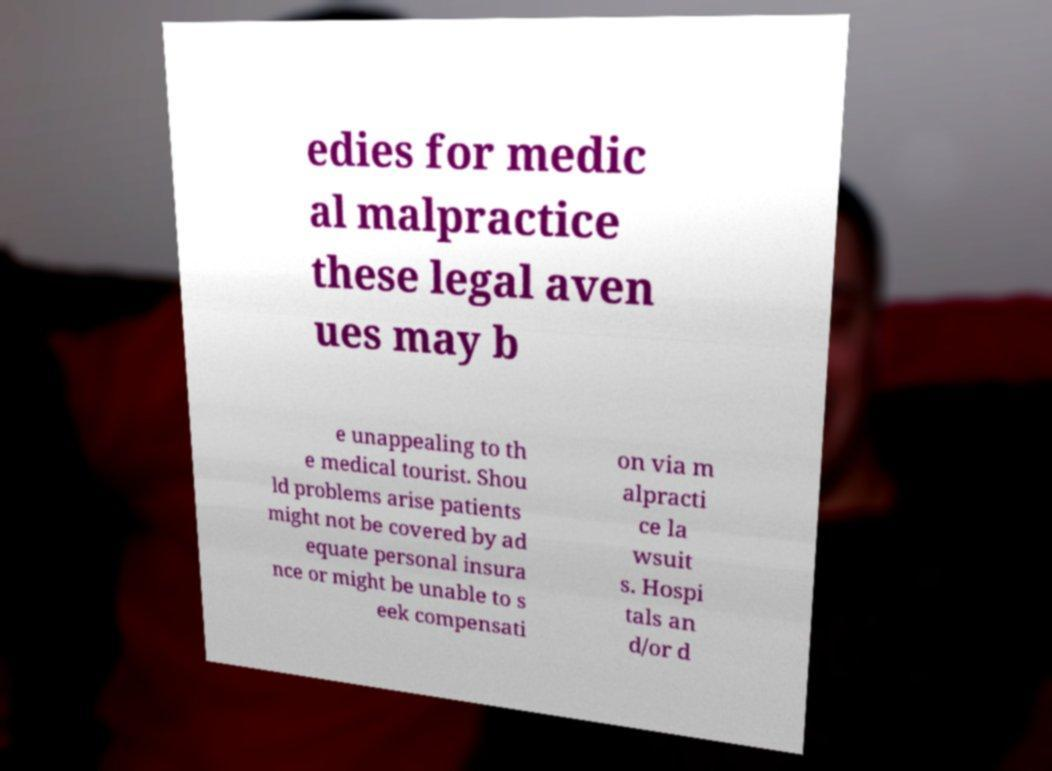Could you assist in decoding the text presented in this image and type it out clearly? edies for medic al malpractice these legal aven ues may b e unappealing to th e medical tourist. Shou ld problems arise patients might not be covered by ad equate personal insura nce or might be unable to s eek compensati on via m alpracti ce la wsuit s. Hospi tals an d/or d 